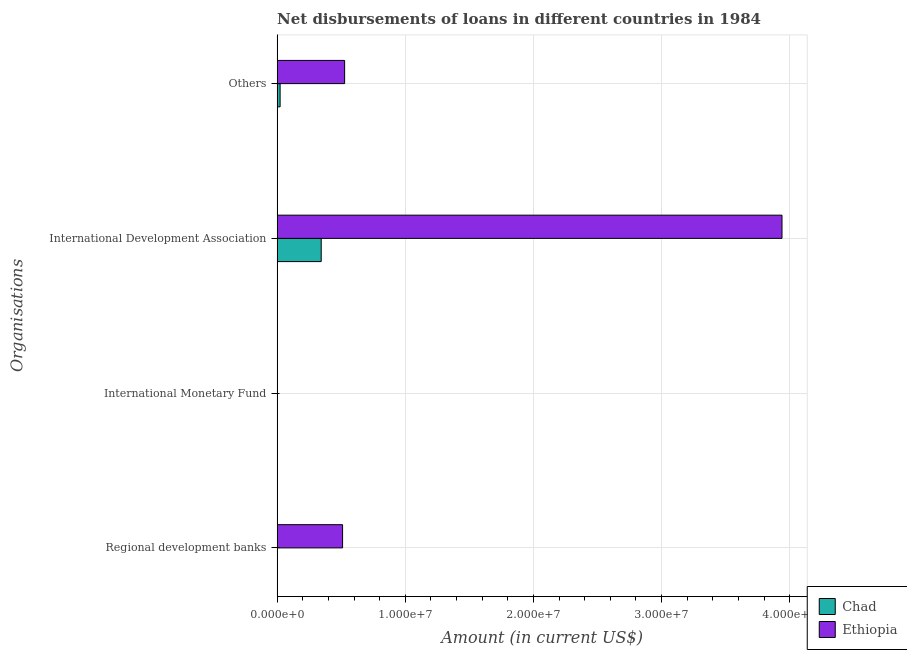Are the number of bars per tick equal to the number of legend labels?
Make the answer very short. No. How many bars are there on the 3rd tick from the top?
Offer a terse response. 0. How many bars are there on the 3rd tick from the bottom?
Your answer should be very brief. 2. What is the label of the 1st group of bars from the top?
Give a very brief answer. Others. What is the amount of loan disimbursed by international development association in Ethiopia?
Give a very brief answer. 3.94e+07. Across all countries, what is the maximum amount of loan disimbursed by other organisations?
Your answer should be very brief. 5.27e+06. Across all countries, what is the minimum amount of loan disimbursed by international development association?
Offer a very short reply. 3.44e+06. In which country was the amount of loan disimbursed by regional development banks maximum?
Make the answer very short. Ethiopia. What is the total amount of loan disimbursed by international development association in the graph?
Offer a terse response. 4.28e+07. What is the difference between the amount of loan disimbursed by international development association in Ethiopia and that in Chad?
Make the answer very short. 3.60e+07. What is the difference between the amount of loan disimbursed by regional development banks in Ethiopia and the amount of loan disimbursed by other organisations in Chad?
Keep it short and to the point. 4.88e+06. What is the difference between the amount of loan disimbursed by other organisations and amount of loan disimbursed by regional development banks in Ethiopia?
Make the answer very short. 1.59e+05. What is the ratio of the amount of loan disimbursed by international development association in Chad to that in Ethiopia?
Keep it short and to the point. 0.09. What is the difference between the highest and the second highest amount of loan disimbursed by other organisations?
Provide a short and direct response. 5.04e+06. What is the difference between the highest and the lowest amount of loan disimbursed by regional development banks?
Make the answer very short. 5.11e+06. In how many countries, is the amount of loan disimbursed by other organisations greater than the average amount of loan disimbursed by other organisations taken over all countries?
Make the answer very short. 1. Is it the case that in every country, the sum of the amount of loan disimbursed by regional development banks and amount of loan disimbursed by international monetary fund is greater than the amount of loan disimbursed by international development association?
Make the answer very short. No. How many bars are there?
Your response must be concise. 5. Are the values on the major ticks of X-axis written in scientific E-notation?
Provide a short and direct response. Yes. Does the graph contain any zero values?
Give a very brief answer. Yes. How many legend labels are there?
Ensure brevity in your answer.  2. What is the title of the graph?
Make the answer very short. Net disbursements of loans in different countries in 1984. What is the label or title of the X-axis?
Provide a short and direct response. Amount (in current US$). What is the label or title of the Y-axis?
Make the answer very short. Organisations. What is the Amount (in current US$) in Chad in Regional development banks?
Give a very brief answer. 0. What is the Amount (in current US$) of Ethiopia in Regional development banks?
Provide a succinct answer. 5.11e+06. What is the Amount (in current US$) of Chad in International Monetary Fund?
Keep it short and to the point. 0. What is the Amount (in current US$) in Chad in International Development Association?
Offer a very short reply. 3.44e+06. What is the Amount (in current US$) in Ethiopia in International Development Association?
Keep it short and to the point. 3.94e+07. What is the Amount (in current US$) of Chad in Others?
Provide a succinct answer. 2.33e+05. What is the Amount (in current US$) of Ethiopia in Others?
Keep it short and to the point. 5.27e+06. Across all Organisations, what is the maximum Amount (in current US$) of Chad?
Your answer should be compact. 3.44e+06. Across all Organisations, what is the maximum Amount (in current US$) of Ethiopia?
Your answer should be very brief. 3.94e+07. Across all Organisations, what is the minimum Amount (in current US$) of Chad?
Offer a very short reply. 0. What is the total Amount (in current US$) of Chad in the graph?
Keep it short and to the point. 3.67e+06. What is the total Amount (in current US$) of Ethiopia in the graph?
Your answer should be very brief. 4.98e+07. What is the difference between the Amount (in current US$) of Ethiopia in Regional development banks and that in International Development Association?
Your answer should be compact. -3.43e+07. What is the difference between the Amount (in current US$) in Ethiopia in Regional development banks and that in Others?
Provide a succinct answer. -1.59e+05. What is the difference between the Amount (in current US$) in Chad in International Development Association and that in Others?
Give a very brief answer. 3.21e+06. What is the difference between the Amount (in current US$) in Ethiopia in International Development Association and that in Others?
Provide a short and direct response. 3.41e+07. What is the difference between the Amount (in current US$) in Chad in International Development Association and the Amount (in current US$) in Ethiopia in Others?
Provide a short and direct response. -1.83e+06. What is the average Amount (in current US$) of Chad per Organisations?
Offer a very short reply. 9.18e+05. What is the average Amount (in current US$) in Ethiopia per Organisations?
Give a very brief answer. 1.24e+07. What is the difference between the Amount (in current US$) in Chad and Amount (in current US$) in Ethiopia in International Development Association?
Your answer should be compact. -3.60e+07. What is the difference between the Amount (in current US$) in Chad and Amount (in current US$) in Ethiopia in Others?
Offer a very short reply. -5.04e+06. What is the ratio of the Amount (in current US$) of Ethiopia in Regional development banks to that in International Development Association?
Your answer should be compact. 0.13. What is the ratio of the Amount (in current US$) of Ethiopia in Regional development banks to that in Others?
Provide a succinct answer. 0.97. What is the ratio of the Amount (in current US$) of Chad in International Development Association to that in Others?
Provide a succinct answer. 14.76. What is the ratio of the Amount (in current US$) in Ethiopia in International Development Association to that in Others?
Offer a very short reply. 7.48. What is the difference between the highest and the second highest Amount (in current US$) of Ethiopia?
Provide a short and direct response. 3.41e+07. What is the difference between the highest and the lowest Amount (in current US$) in Chad?
Keep it short and to the point. 3.44e+06. What is the difference between the highest and the lowest Amount (in current US$) of Ethiopia?
Ensure brevity in your answer.  3.94e+07. 